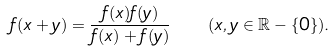<formula> <loc_0><loc_0><loc_500><loc_500>f ( x + y ) = \frac { f ( x ) f ( y ) } { f ( x ) + f ( y ) } \quad ( x , y \in \mathbb { R } - \{ 0 \} ) .</formula> 